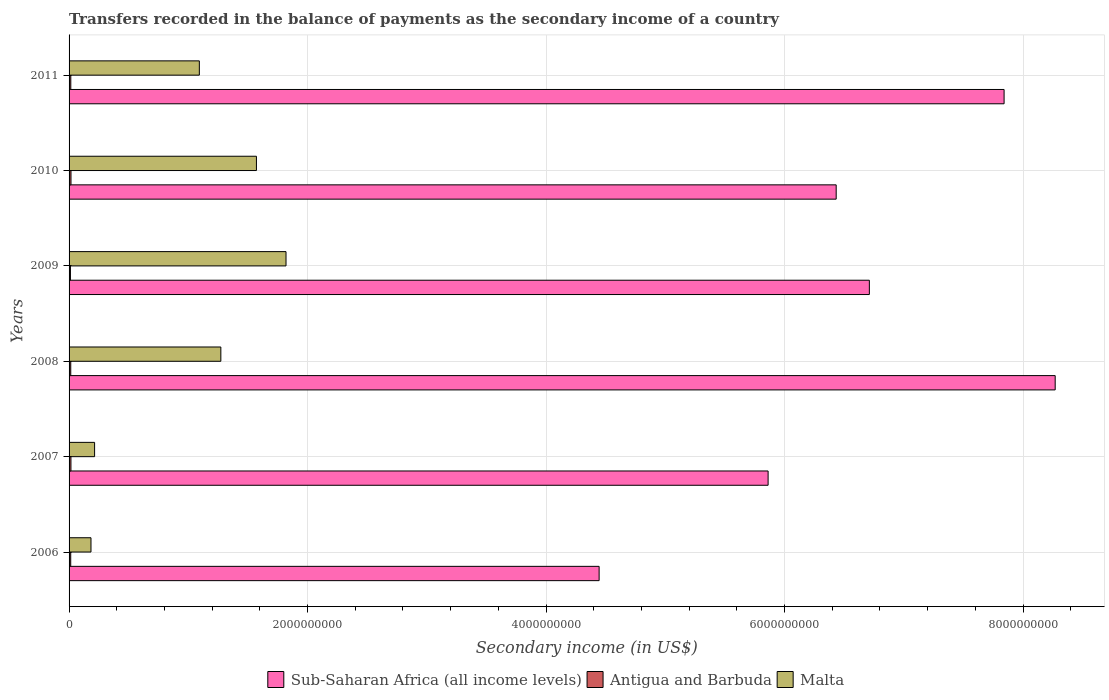How many bars are there on the 5th tick from the top?
Give a very brief answer. 3. In how many cases, is the number of bars for a given year not equal to the number of legend labels?
Your response must be concise. 0. What is the secondary income of in Malta in 2008?
Your answer should be compact. 1.27e+09. Across all years, what is the maximum secondary income of in Sub-Saharan Africa (all income levels)?
Offer a very short reply. 8.27e+09. Across all years, what is the minimum secondary income of in Malta?
Offer a terse response. 1.84e+08. In which year was the secondary income of in Antigua and Barbuda maximum?
Offer a terse response. 2010. In which year was the secondary income of in Antigua and Barbuda minimum?
Provide a short and direct response. 2009. What is the total secondary income of in Antigua and Barbuda in the graph?
Make the answer very short. 8.55e+07. What is the difference between the secondary income of in Antigua and Barbuda in 2008 and that in 2009?
Make the answer very short. 2.59e+06. What is the difference between the secondary income of in Malta in 2006 and the secondary income of in Antigua and Barbuda in 2009?
Offer a very short reply. 1.72e+08. What is the average secondary income of in Antigua and Barbuda per year?
Provide a succinct answer. 1.42e+07. In the year 2006, what is the difference between the secondary income of in Sub-Saharan Africa (all income levels) and secondary income of in Malta?
Offer a terse response. 4.26e+09. What is the ratio of the secondary income of in Antigua and Barbuda in 2006 to that in 2009?
Give a very brief answer. 1.21. What is the difference between the highest and the second highest secondary income of in Malta?
Offer a terse response. 2.48e+08. What is the difference between the highest and the lowest secondary income of in Antigua and Barbuda?
Keep it short and to the point. 4.58e+06. In how many years, is the secondary income of in Antigua and Barbuda greater than the average secondary income of in Antigua and Barbuda taken over all years?
Provide a short and direct response. 3. What does the 2nd bar from the top in 2006 represents?
Your answer should be very brief. Antigua and Barbuda. What does the 2nd bar from the bottom in 2011 represents?
Offer a terse response. Antigua and Barbuda. Is it the case that in every year, the sum of the secondary income of in Malta and secondary income of in Sub-Saharan Africa (all income levels) is greater than the secondary income of in Antigua and Barbuda?
Make the answer very short. Yes. Are all the bars in the graph horizontal?
Keep it short and to the point. Yes. How many years are there in the graph?
Your answer should be very brief. 6. Does the graph contain any zero values?
Offer a terse response. No. Does the graph contain grids?
Your answer should be compact. Yes. How many legend labels are there?
Offer a very short reply. 3. How are the legend labels stacked?
Provide a succinct answer. Horizontal. What is the title of the graph?
Your response must be concise. Transfers recorded in the balance of payments as the secondary income of a country. What is the label or title of the X-axis?
Your answer should be compact. Secondary income (in US$). What is the Secondary income (in US$) of Sub-Saharan Africa (all income levels) in 2006?
Your answer should be very brief. 4.45e+09. What is the Secondary income (in US$) of Antigua and Barbuda in 2006?
Your answer should be very brief. 1.39e+07. What is the Secondary income (in US$) in Malta in 2006?
Offer a terse response. 1.84e+08. What is the Secondary income (in US$) of Sub-Saharan Africa (all income levels) in 2007?
Give a very brief answer. 5.86e+09. What is the Secondary income (in US$) in Antigua and Barbuda in 2007?
Your response must be concise. 1.56e+07. What is the Secondary income (in US$) of Malta in 2007?
Your response must be concise. 2.14e+08. What is the Secondary income (in US$) in Sub-Saharan Africa (all income levels) in 2008?
Make the answer very short. 8.27e+09. What is the Secondary income (in US$) in Antigua and Barbuda in 2008?
Provide a succinct answer. 1.40e+07. What is the Secondary income (in US$) of Malta in 2008?
Provide a short and direct response. 1.27e+09. What is the Secondary income (in US$) in Sub-Saharan Africa (all income levels) in 2009?
Provide a short and direct response. 6.71e+09. What is the Secondary income (in US$) of Antigua and Barbuda in 2009?
Offer a terse response. 1.14e+07. What is the Secondary income (in US$) in Malta in 2009?
Your response must be concise. 1.82e+09. What is the Secondary income (in US$) in Sub-Saharan Africa (all income levels) in 2010?
Ensure brevity in your answer.  6.43e+09. What is the Secondary income (in US$) of Antigua and Barbuda in 2010?
Your answer should be very brief. 1.60e+07. What is the Secondary income (in US$) of Malta in 2010?
Your response must be concise. 1.57e+09. What is the Secondary income (in US$) of Sub-Saharan Africa (all income levels) in 2011?
Your answer should be very brief. 7.84e+09. What is the Secondary income (in US$) in Antigua and Barbuda in 2011?
Keep it short and to the point. 1.45e+07. What is the Secondary income (in US$) of Malta in 2011?
Your answer should be compact. 1.09e+09. Across all years, what is the maximum Secondary income (in US$) in Sub-Saharan Africa (all income levels)?
Give a very brief answer. 8.27e+09. Across all years, what is the maximum Secondary income (in US$) in Antigua and Barbuda?
Your answer should be very brief. 1.60e+07. Across all years, what is the maximum Secondary income (in US$) of Malta?
Make the answer very short. 1.82e+09. Across all years, what is the minimum Secondary income (in US$) in Sub-Saharan Africa (all income levels)?
Your answer should be very brief. 4.45e+09. Across all years, what is the minimum Secondary income (in US$) in Antigua and Barbuda?
Keep it short and to the point. 1.14e+07. Across all years, what is the minimum Secondary income (in US$) in Malta?
Provide a short and direct response. 1.84e+08. What is the total Secondary income (in US$) of Sub-Saharan Africa (all income levels) in the graph?
Ensure brevity in your answer.  3.96e+1. What is the total Secondary income (in US$) of Antigua and Barbuda in the graph?
Offer a terse response. 8.55e+07. What is the total Secondary income (in US$) in Malta in the graph?
Your response must be concise. 6.15e+09. What is the difference between the Secondary income (in US$) in Sub-Saharan Africa (all income levels) in 2006 and that in 2007?
Give a very brief answer. -1.42e+09. What is the difference between the Secondary income (in US$) of Antigua and Barbuda in 2006 and that in 2007?
Give a very brief answer. -1.71e+06. What is the difference between the Secondary income (in US$) of Malta in 2006 and that in 2007?
Offer a very short reply. -3.03e+07. What is the difference between the Secondary income (in US$) of Sub-Saharan Africa (all income levels) in 2006 and that in 2008?
Your response must be concise. -3.82e+09. What is the difference between the Secondary income (in US$) of Antigua and Barbuda in 2006 and that in 2008?
Give a very brief answer. -1.47e+05. What is the difference between the Secondary income (in US$) in Malta in 2006 and that in 2008?
Offer a very short reply. -1.09e+09. What is the difference between the Secondary income (in US$) of Sub-Saharan Africa (all income levels) in 2006 and that in 2009?
Provide a short and direct response. -2.27e+09. What is the difference between the Secondary income (in US$) in Antigua and Barbuda in 2006 and that in 2009?
Provide a succinct answer. 2.44e+06. What is the difference between the Secondary income (in US$) of Malta in 2006 and that in 2009?
Give a very brief answer. -1.64e+09. What is the difference between the Secondary income (in US$) of Sub-Saharan Africa (all income levels) in 2006 and that in 2010?
Provide a succinct answer. -1.99e+09. What is the difference between the Secondary income (in US$) in Antigua and Barbuda in 2006 and that in 2010?
Make the answer very short. -2.14e+06. What is the difference between the Secondary income (in US$) in Malta in 2006 and that in 2010?
Provide a short and direct response. -1.39e+09. What is the difference between the Secondary income (in US$) of Sub-Saharan Africa (all income levels) in 2006 and that in 2011?
Make the answer very short. -3.40e+09. What is the difference between the Secondary income (in US$) in Antigua and Barbuda in 2006 and that in 2011?
Make the answer very short. -6.30e+05. What is the difference between the Secondary income (in US$) in Malta in 2006 and that in 2011?
Your response must be concise. -9.09e+08. What is the difference between the Secondary income (in US$) of Sub-Saharan Africa (all income levels) in 2007 and that in 2008?
Give a very brief answer. -2.41e+09. What is the difference between the Secondary income (in US$) in Antigua and Barbuda in 2007 and that in 2008?
Keep it short and to the point. 1.57e+06. What is the difference between the Secondary income (in US$) of Malta in 2007 and that in 2008?
Keep it short and to the point. -1.06e+09. What is the difference between the Secondary income (in US$) of Sub-Saharan Africa (all income levels) in 2007 and that in 2009?
Ensure brevity in your answer.  -8.49e+08. What is the difference between the Secondary income (in US$) in Antigua and Barbuda in 2007 and that in 2009?
Ensure brevity in your answer.  4.15e+06. What is the difference between the Secondary income (in US$) of Malta in 2007 and that in 2009?
Provide a succinct answer. -1.61e+09. What is the difference between the Secondary income (in US$) of Sub-Saharan Africa (all income levels) in 2007 and that in 2010?
Your response must be concise. -5.71e+08. What is the difference between the Secondary income (in US$) of Antigua and Barbuda in 2007 and that in 2010?
Your answer should be compact. -4.28e+05. What is the difference between the Secondary income (in US$) of Malta in 2007 and that in 2010?
Ensure brevity in your answer.  -1.36e+09. What is the difference between the Secondary income (in US$) of Sub-Saharan Africa (all income levels) in 2007 and that in 2011?
Provide a succinct answer. -1.98e+09. What is the difference between the Secondary income (in US$) of Antigua and Barbuda in 2007 and that in 2011?
Your answer should be very brief. 1.08e+06. What is the difference between the Secondary income (in US$) in Malta in 2007 and that in 2011?
Make the answer very short. -8.78e+08. What is the difference between the Secondary income (in US$) in Sub-Saharan Africa (all income levels) in 2008 and that in 2009?
Provide a short and direct response. 1.56e+09. What is the difference between the Secondary income (in US$) in Antigua and Barbuda in 2008 and that in 2009?
Your answer should be compact. 2.59e+06. What is the difference between the Secondary income (in US$) of Malta in 2008 and that in 2009?
Offer a terse response. -5.47e+08. What is the difference between the Secondary income (in US$) in Sub-Saharan Africa (all income levels) in 2008 and that in 2010?
Your answer should be very brief. 1.84e+09. What is the difference between the Secondary income (in US$) in Antigua and Barbuda in 2008 and that in 2010?
Make the answer very short. -2.00e+06. What is the difference between the Secondary income (in US$) of Malta in 2008 and that in 2010?
Offer a very short reply. -2.99e+08. What is the difference between the Secondary income (in US$) of Sub-Saharan Africa (all income levels) in 2008 and that in 2011?
Your answer should be compact. 4.28e+08. What is the difference between the Secondary income (in US$) in Antigua and Barbuda in 2008 and that in 2011?
Your response must be concise. -4.83e+05. What is the difference between the Secondary income (in US$) in Malta in 2008 and that in 2011?
Provide a short and direct response. 1.80e+08. What is the difference between the Secondary income (in US$) in Sub-Saharan Africa (all income levels) in 2009 and that in 2010?
Offer a terse response. 2.78e+08. What is the difference between the Secondary income (in US$) in Antigua and Barbuda in 2009 and that in 2010?
Your answer should be compact. -4.58e+06. What is the difference between the Secondary income (in US$) of Malta in 2009 and that in 2010?
Offer a terse response. 2.48e+08. What is the difference between the Secondary income (in US$) in Sub-Saharan Africa (all income levels) in 2009 and that in 2011?
Give a very brief answer. -1.13e+09. What is the difference between the Secondary income (in US$) in Antigua and Barbuda in 2009 and that in 2011?
Keep it short and to the point. -3.07e+06. What is the difference between the Secondary income (in US$) of Malta in 2009 and that in 2011?
Give a very brief answer. 7.27e+08. What is the difference between the Secondary income (in US$) of Sub-Saharan Africa (all income levels) in 2010 and that in 2011?
Your response must be concise. -1.41e+09. What is the difference between the Secondary income (in US$) of Antigua and Barbuda in 2010 and that in 2011?
Offer a very short reply. 1.51e+06. What is the difference between the Secondary income (in US$) in Malta in 2010 and that in 2011?
Your answer should be very brief. 4.79e+08. What is the difference between the Secondary income (in US$) of Sub-Saharan Africa (all income levels) in 2006 and the Secondary income (in US$) of Antigua and Barbuda in 2007?
Provide a succinct answer. 4.43e+09. What is the difference between the Secondary income (in US$) in Sub-Saharan Africa (all income levels) in 2006 and the Secondary income (in US$) in Malta in 2007?
Offer a terse response. 4.23e+09. What is the difference between the Secondary income (in US$) in Antigua and Barbuda in 2006 and the Secondary income (in US$) in Malta in 2007?
Your answer should be compact. -2.00e+08. What is the difference between the Secondary income (in US$) in Sub-Saharan Africa (all income levels) in 2006 and the Secondary income (in US$) in Antigua and Barbuda in 2008?
Ensure brevity in your answer.  4.43e+09. What is the difference between the Secondary income (in US$) in Sub-Saharan Africa (all income levels) in 2006 and the Secondary income (in US$) in Malta in 2008?
Make the answer very short. 3.17e+09. What is the difference between the Secondary income (in US$) in Antigua and Barbuda in 2006 and the Secondary income (in US$) in Malta in 2008?
Your answer should be very brief. -1.26e+09. What is the difference between the Secondary income (in US$) in Sub-Saharan Africa (all income levels) in 2006 and the Secondary income (in US$) in Antigua and Barbuda in 2009?
Keep it short and to the point. 4.43e+09. What is the difference between the Secondary income (in US$) in Sub-Saharan Africa (all income levels) in 2006 and the Secondary income (in US$) in Malta in 2009?
Ensure brevity in your answer.  2.63e+09. What is the difference between the Secondary income (in US$) in Antigua and Barbuda in 2006 and the Secondary income (in US$) in Malta in 2009?
Provide a short and direct response. -1.81e+09. What is the difference between the Secondary income (in US$) in Sub-Saharan Africa (all income levels) in 2006 and the Secondary income (in US$) in Antigua and Barbuda in 2010?
Give a very brief answer. 4.43e+09. What is the difference between the Secondary income (in US$) of Sub-Saharan Africa (all income levels) in 2006 and the Secondary income (in US$) of Malta in 2010?
Provide a short and direct response. 2.87e+09. What is the difference between the Secondary income (in US$) of Antigua and Barbuda in 2006 and the Secondary income (in US$) of Malta in 2010?
Offer a very short reply. -1.56e+09. What is the difference between the Secondary income (in US$) of Sub-Saharan Africa (all income levels) in 2006 and the Secondary income (in US$) of Antigua and Barbuda in 2011?
Keep it short and to the point. 4.43e+09. What is the difference between the Secondary income (in US$) in Sub-Saharan Africa (all income levels) in 2006 and the Secondary income (in US$) in Malta in 2011?
Provide a succinct answer. 3.35e+09. What is the difference between the Secondary income (in US$) in Antigua and Barbuda in 2006 and the Secondary income (in US$) in Malta in 2011?
Offer a very short reply. -1.08e+09. What is the difference between the Secondary income (in US$) in Sub-Saharan Africa (all income levels) in 2007 and the Secondary income (in US$) in Antigua and Barbuda in 2008?
Your response must be concise. 5.85e+09. What is the difference between the Secondary income (in US$) in Sub-Saharan Africa (all income levels) in 2007 and the Secondary income (in US$) in Malta in 2008?
Ensure brevity in your answer.  4.59e+09. What is the difference between the Secondary income (in US$) in Antigua and Barbuda in 2007 and the Secondary income (in US$) in Malta in 2008?
Provide a succinct answer. -1.26e+09. What is the difference between the Secondary income (in US$) in Sub-Saharan Africa (all income levels) in 2007 and the Secondary income (in US$) in Antigua and Barbuda in 2009?
Provide a short and direct response. 5.85e+09. What is the difference between the Secondary income (in US$) in Sub-Saharan Africa (all income levels) in 2007 and the Secondary income (in US$) in Malta in 2009?
Offer a very short reply. 4.04e+09. What is the difference between the Secondary income (in US$) in Antigua and Barbuda in 2007 and the Secondary income (in US$) in Malta in 2009?
Your response must be concise. -1.80e+09. What is the difference between the Secondary income (in US$) in Sub-Saharan Africa (all income levels) in 2007 and the Secondary income (in US$) in Antigua and Barbuda in 2010?
Your answer should be very brief. 5.85e+09. What is the difference between the Secondary income (in US$) in Sub-Saharan Africa (all income levels) in 2007 and the Secondary income (in US$) in Malta in 2010?
Make the answer very short. 4.29e+09. What is the difference between the Secondary income (in US$) of Antigua and Barbuda in 2007 and the Secondary income (in US$) of Malta in 2010?
Offer a very short reply. -1.56e+09. What is the difference between the Secondary income (in US$) of Sub-Saharan Africa (all income levels) in 2007 and the Secondary income (in US$) of Antigua and Barbuda in 2011?
Give a very brief answer. 5.85e+09. What is the difference between the Secondary income (in US$) of Sub-Saharan Africa (all income levels) in 2007 and the Secondary income (in US$) of Malta in 2011?
Give a very brief answer. 4.77e+09. What is the difference between the Secondary income (in US$) of Antigua and Barbuda in 2007 and the Secondary income (in US$) of Malta in 2011?
Offer a terse response. -1.08e+09. What is the difference between the Secondary income (in US$) in Sub-Saharan Africa (all income levels) in 2008 and the Secondary income (in US$) in Antigua and Barbuda in 2009?
Provide a succinct answer. 8.26e+09. What is the difference between the Secondary income (in US$) in Sub-Saharan Africa (all income levels) in 2008 and the Secondary income (in US$) in Malta in 2009?
Provide a short and direct response. 6.45e+09. What is the difference between the Secondary income (in US$) of Antigua and Barbuda in 2008 and the Secondary income (in US$) of Malta in 2009?
Keep it short and to the point. -1.81e+09. What is the difference between the Secondary income (in US$) in Sub-Saharan Africa (all income levels) in 2008 and the Secondary income (in US$) in Antigua and Barbuda in 2010?
Give a very brief answer. 8.25e+09. What is the difference between the Secondary income (in US$) in Sub-Saharan Africa (all income levels) in 2008 and the Secondary income (in US$) in Malta in 2010?
Make the answer very short. 6.70e+09. What is the difference between the Secondary income (in US$) in Antigua and Barbuda in 2008 and the Secondary income (in US$) in Malta in 2010?
Ensure brevity in your answer.  -1.56e+09. What is the difference between the Secondary income (in US$) in Sub-Saharan Africa (all income levels) in 2008 and the Secondary income (in US$) in Antigua and Barbuda in 2011?
Your answer should be very brief. 8.26e+09. What is the difference between the Secondary income (in US$) in Sub-Saharan Africa (all income levels) in 2008 and the Secondary income (in US$) in Malta in 2011?
Offer a terse response. 7.18e+09. What is the difference between the Secondary income (in US$) in Antigua and Barbuda in 2008 and the Secondary income (in US$) in Malta in 2011?
Keep it short and to the point. -1.08e+09. What is the difference between the Secondary income (in US$) of Sub-Saharan Africa (all income levels) in 2009 and the Secondary income (in US$) of Antigua and Barbuda in 2010?
Keep it short and to the point. 6.70e+09. What is the difference between the Secondary income (in US$) of Sub-Saharan Africa (all income levels) in 2009 and the Secondary income (in US$) of Malta in 2010?
Provide a short and direct response. 5.14e+09. What is the difference between the Secondary income (in US$) in Antigua and Barbuda in 2009 and the Secondary income (in US$) in Malta in 2010?
Offer a terse response. -1.56e+09. What is the difference between the Secondary income (in US$) of Sub-Saharan Africa (all income levels) in 2009 and the Secondary income (in US$) of Antigua and Barbuda in 2011?
Give a very brief answer. 6.70e+09. What is the difference between the Secondary income (in US$) of Sub-Saharan Africa (all income levels) in 2009 and the Secondary income (in US$) of Malta in 2011?
Offer a terse response. 5.62e+09. What is the difference between the Secondary income (in US$) of Antigua and Barbuda in 2009 and the Secondary income (in US$) of Malta in 2011?
Make the answer very short. -1.08e+09. What is the difference between the Secondary income (in US$) in Sub-Saharan Africa (all income levels) in 2010 and the Secondary income (in US$) in Antigua and Barbuda in 2011?
Offer a very short reply. 6.42e+09. What is the difference between the Secondary income (in US$) of Sub-Saharan Africa (all income levels) in 2010 and the Secondary income (in US$) of Malta in 2011?
Offer a terse response. 5.34e+09. What is the difference between the Secondary income (in US$) of Antigua and Barbuda in 2010 and the Secondary income (in US$) of Malta in 2011?
Provide a short and direct response. -1.08e+09. What is the average Secondary income (in US$) in Sub-Saharan Africa (all income levels) per year?
Give a very brief answer. 6.59e+09. What is the average Secondary income (in US$) in Antigua and Barbuda per year?
Keep it short and to the point. 1.42e+07. What is the average Secondary income (in US$) of Malta per year?
Your response must be concise. 1.03e+09. In the year 2006, what is the difference between the Secondary income (in US$) in Sub-Saharan Africa (all income levels) and Secondary income (in US$) in Antigua and Barbuda?
Provide a succinct answer. 4.43e+09. In the year 2006, what is the difference between the Secondary income (in US$) in Sub-Saharan Africa (all income levels) and Secondary income (in US$) in Malta?
Provide a short and direct response. 4.26e+09. In the year 2006, what is the difference between the Secondary income (in US$) of Antigua and Barbuda and Secondary income (in US$) of Malta?
Give a very brief answer. -1.70e+08. In the year 2007, what is the difference between the Secondary income (in US$) in Sub-Saharan Africa (all income levels) and Secondary income (in US$) in Antigua and Barbuda?
Give a very brief answer. 5.85e+09. In the year 2007, what is the difference between the Secondary income (in US$) in Sub-Saharan Africa (all income levels) and Secondary income (in US$) in Malta?
Your answer should be very brief. 5.65e+09. In the year 2007, what is the difference between the Secondary income (in US$) in Antigua and Barbuda and Secondary income (in US$) in Malta?
Your answer should be compact. -1.98e+08. In the year 2008, what is the difference between the Secondary income (in US$) of Sub-Saharan Africa (all income levels) and Secondary income (in US$) of Antigua and Barbuda?
Keep it short and to the point. 8.26e+09. In the year 2008, what is the difference between the Secondary income (in US$) in Sub-Saharan Africa (all income levels) and Secondary income (in US$) in Malta?
Make the answer very short. 7.00e+09. In the year 2008, what is the difference between the Secondary income (in US$) of Antigua and Barbuda and Secondary income (in US$) of Malta?
Ensure brevity in your answer.  -1.26e+09. In the year 2009, what is the difference between the Secondary income (in US$) in Sub-Saharan Africa (all income levels) and Secondary income (in US$) in Antigua and Barbuda?
Keep it short and to the point. 6.70e+09. In the year 2009, what is the difference between the Secondary income (in US$) of Sub-Saharan Africa (all income levels) and Secondary income (in US$) of Malta?
Provide a short and direct response. 4.89e+09. In the year 2009, what is the difference between the Secondary income (in US$) of Antigua and Barbuda and Secondary income (in US$) of Malta?
Your answer should be very brief. -1.81e+09. In the year 2010, what is the difference between the Secondary income (in US$) in Sub-Saharan Africa (all income levels) and Secondary income (in US$) in Antigua and Barbuda?
Ensure brevity in your answer.  6.42e+09. In the year 2010, what is the difference between the Secondary income (in US$) of Sub-Saharan Africa (all income levels) and Secondary income (in US$) of Malta?
Offer a terse response. 4.86e+09. In the year 2010, what is the difference between the Secondary income (in US$) of Antigua and Barbuda and Secondary income (in US$) of Malta?
Your answer should be very brief. -1.56e+09. In the year 2011, what is the difference between the Secondary income (in US$) in Sub-Saharan Africa (all income levels) and Secondary income (in US$) in Antigua and Barbuda?
Give a very brief answer. 7.83e+09. In the year 2011, what is the difference between the Secondary income (in US$) of Sub-Saharan Africa (all income levels) and Secondary income (in US$) of Malta?
Ensure brevity in your answer.  6.75e+09. In the year 2011, what is the difference between the Secondary income (in US$) in Antigua and Barbuda and Secondary income (in US$) in Malta?
Ensure brevity in your answer.  -1.08e+09. What is the ratio of the Secondary income (in US$) of Sub-Saharan Africa (all income levels) in 2006 to that in 2007?
Make the answer very short. 0.76. What is the ratio of the Secondary income (in US$) of Antigua and Barbuda in 2006 to that in 2007?
Offer a very short reply. 0.89. What is the ratio of the Secondary income (in US$) in Malta in 2006 to that in 2007?
Keep it short and to the point. 0.86. What is the ratio of the Secondary income (in US$) of Sub-Saharan Africa (all income levels) in 2006 to that in 2008?
Your response must be concise. 0.54. What is the ratio of the Secondary income (in US$) in Malta in 2006 to that in 2008?
Offer a very short reply. 0.14. What is the ratio of the Secondary income (in US$) in Sub-Saharan Africa (all income levels) in 2006 to that in 2009?
Make the answer very short. 0.66. What is the ratio of the Secondary income (in US$) in Antigua and Barbuda in 2006 to that in 2009?
Your response must be concise. 1.21. What is the ratio of the Secondary income (in US$) in Malta in 2006 to that in 2009?
Your response must be concise. 0.1. What is the ratio of the Secondary income (in US$) of Sub-Saharan Africa (all income levels) in 2006 to that in 2010?
Your answer should be compact. 0.69. What is the ratio of the Secondary income (in US$) in Antigua and Barbuda in 2006 to that in 2010?
Provide a short and direct response. 0.87. What is the ratio of the Secondary income (in US$) of Malta in 2006 to that in 2010?
Your response must be concise. 0.12. What is the ratio of the Secondary income (in US$) in Sub-Saharan Africa (all income levels) in 2006 to that in 2011?
Provide a succinct answer. 0.57. What is the ratio of the Secondary income (in US$) in Antigua and Barbuda in 2006 to that in 2011?
Provide a short and direct response. 0.96. What is the ratio of the Secondary income (in US$) of Malta in 2006 to that in 2011?
Ensure brevity in your answer.  0.17. What is the ratio of the Secondary income (in US$) in Sub-Saharan Africa (all income levels) in 2007 to that in 2008?
Give a very brief answer. 0.71. What is the ratio of the Secondary income (in US$) of Antigua and Barbuda in 2007 to that in 2008?
Your answer should be very brief. 1.11. What is the ratio of the Secondary income (in US$) of Malta in 2007 to that in 2008?
Keep it short and to the point. 0.17. What is the ratio of the Secondary income (in US$) of Sub-Saharan Africa (all income levels) in 2007 to that in 2009?
Provide a short and direct response. 0.87. What is the ratio of the Secondary income (in US$) in Antigua and Barbuda in 2007 to that in 2009?
Ensure brevity in your answer.  1.36. What is the ratio of the Secondary income (in US$) in Malta in 2007 to that in 2009?
Provide a short and direct response. 0.12. What is the ratio of the Secondary income (in US$) in Sub-Saharan Africa (all income levels) in 2007 to that in 2010?
Make the answer very short. 0.91. What is the ratio of the Secondary income (in US$) of Antigua and Barbuda in 2007 to that in 2010?
Provide a succinct answer. 0.97. What is the ratio of the Secondary income (in US$) of Malta in 2007 to that in 2010?
Make the answer very short. 0.14. What is the ratio of the Secondary income (in US$) in Sub-Saharan Africa (all income levels) in 2007 to that in 2011?
Provide a succinct answer. 0.75. What is the ratio of the Secondary income (in US$) in Antigua and Barbuda in 2007 to that in 2011?
Make the answer very short. 1.07. What is the ratio of the Secondary income (in US$) in Malta in 2007 to that in 2011?
Provide a short and direct response. 0.2. What is the ratio of the Secondary income (in US$) of Sub-Saharan Africa (all income levels) in 2008 to that in 2009?
Provide a succinct answer. 1.23. What is the ratio of the Secondary income (in US$) of Antigua and Barbuda in 2008 to that in 2009?
Offer a terse response. 1.23. What is the ratio of the Secondary income (in US$) in Malta in 2008 to that in 2009?
Keep it short and to the point. 0.7. What is the ratio of the Secondary income (in US$) in Sub-Saharan Africa (all income levels) in 2008 to that in 2010?
Your answer should be compact. 1.29. What is the ratio of the Secondary income (in US$) in Antigua and Barbuda in 2008 to that in 2010?
Provide a succinct answer. 0.88. What is the ratio of the Secondary income (in US$) of Malta in 2008 to that in 2010?
Give a very brief answer. 0.81. What is the ratio of the Secondary income (in US$) of Sub-Saharan Africa (all income levels) in 2008 to that in 2011?
Your response must be concise. 1.05. What is the ratio of the Secondary income (in US$) of Antigua and Barbuda in 2008 to that in 2011?
Your answer should be very brief. 0.97. What is the ratio of the Secondary income (in US$) of Malta in 2008 to that in 2011?
Offer a terse response. 1.17. What is the ratio of the Secondary income (in US$) of Sub-Saharan Africa (all income levels) in 2009 to that in 2010?
Ensure brevity in your answer.  1.04. What is the ratio of the Secondary income (in US$) in Antigua and Barbuda in 2009 to that in 2010?
Offer a terse response. 0.71. What is the ratio of the Secondary income (in US$) in Malta in 2009 to that in 2010?
Your answer should be very brief. 1.16. What is the ratio of the Secondary income (in US$) of Sub-Saharan Africa (all income levels) in 2009 to that in 2011?
Give a very brief answer. 0.86. What is the ratio of the Secondary income (in US$) in Antigua and Barbuda in 2009 to that in 2011?
Provide a short and direct response. 0.79. What is the ratio of the Secondary income (in US$) of Malta in 2009 to that in 2011?
Provide a short and direct response. 1.67. What is the ratio of the Secondary income (in US$) of Sub-Saharan Africa (all income levels) in 2010 to that in 2011?
Ensure brevity in your answer.  0.82. What is the ratio of the Secondary income (in US$) in Antigua and Barbuda in 2010 to that in 2011?
Give a very brief answer. 1.1. What is the ratio of the Secondary income (in US$) in Malta in 2010 to that in 2011?
Offer a terse response. 1.44. What is the difference between the highest and the second highest Secondary income (in US$) of Sub-Saharan Africa (all income levels)?
Provide a succinct answer. 4.28e+08. What is the difference between the highest and the second highest Secondary income (in US$) in Antigua and Barbuda?
Your response must be concise. 4.28e+05. What is the difference between the highest and the second highest Secondary income (in US$) of Malta?
Offer a very short reply. 2.48e+08. What is the difference between the highest and the lowest Secondary income (in US$) in Sub-Saharan Africa (all income levels)?
Provide a short and direct response. 3.82e+09. What is the difference between the highest and the lowest Secondary income (in US$) of Antigua and Barbuda?
Keep it short and to the point. 4.58e+06. What is the difference between the highest and the lowest Secondary income (in US$) in Malta?
Offer a terse response. 1.64e+09. 